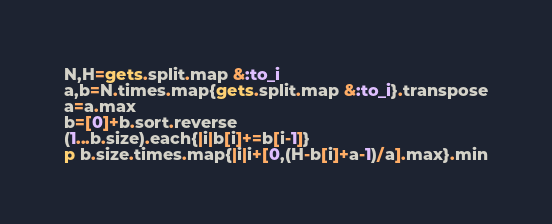<code> <loc_0><loc_0><loc_500><loc_500><_Ruby_>N,H=gets.split.map &:to_i
a,b=N.times.map{gets.split.map &:to_i}.transpose
a=a.max
b=[0]+b.sort.reverse
(1...b.size).each{|i|b[i]+=b[i-1]}
p b.size.times.map{|i|i+[0,(H-b[i]+a-1)/a].max}.min</code> 